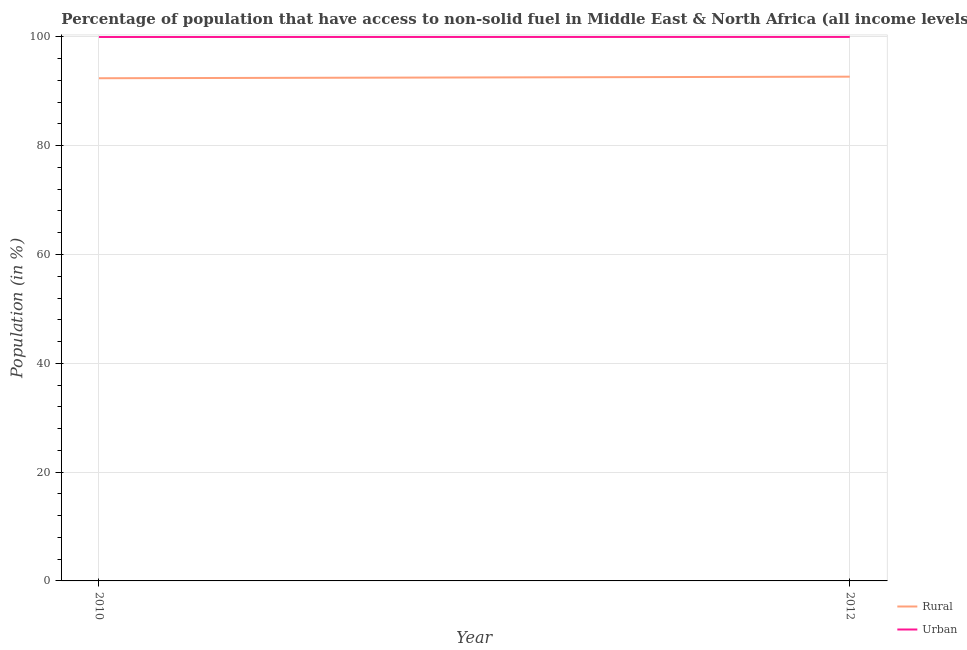Does the line corresponding to rural population intersect with the line corresponding to urban population?
Provide a succinct answer. No. Is the number of lines equal to the number of legend labels?
Ensure brevity in your answer.  Yes. What is the urban population in 2010?
Provide a succinct answer. 99.98. Across all years, what is the maximum urban population?
Provide a succinct answer. 99.99. Across all years, what is the minimum rural population?
Your answer should be very brief. 92.4. In which year was the rural population maximum?
Give a very brief answer. 2012. What is the total urban population in the graph?
Provide a succinct answer. 199.97. What is the difference between the rural population in 2010 and that in 2012?
Provide a succinct answer. -0.29. What is the difference between the urban population in 2012 and the rural population in 2010?
Ensure brevity in your answer.  7.59. What is the average rural population per year?
Offer a very short reply. 92.54. In the year 2012, what is the difference between the rural population and urban population?
Offer a terse response. -7.31. What is the ratio of the urban population in 2010 to that in 2012?
Offer a terse response. 1. Is the rural population strictly greater than the urban population over the years?
Offer a terse response. No. Is the rural population strictly less than the urban population over the years?
Ensure brevity in your answer.  Yes. What is the difference between two consecutive major ticks on the Y-axis?
Give a very brief answer. 20. How are the legend labels stacked?
Offer a terse response. Vertical. What is the title of the graph?
Provide a short and direct response. Percentage of population that have access to non-solid fuel in Middle East & North Africa (all income levels). What is the Population (in %) in Rural in 2010?
Offer a very short reply. 92.4. What is the Population (in %) of Urban in 2010?
Your response must be concise. 99.98. What is the Population (in %) in Rural in 2012?
Your answer should be very brief. 92.69. What is the Population (in %) of Urban in 2012?
Offer a very short reply. 99.99. Across all years, what is the maximum Population (in %) of Rural?
Offer a terse response. 92.69. Across all years, what is the maximum Population (in %) of Urban?
Provide a short and direct response. 99.99. Across all years, what is the minimum Population (in %) in Rural?
Provide a succinct answer. 92.4. Across all years, what is the minimum Population (in %) of Urban?
Ensure brevity in your answer.  99.98. What is the total Population (in %) in Rural in the graph?
Your answer should be very brief. 185.09. What is the total Population (in %) of Urban in the graph?
Your answer should be very brief. 199.97. What is the difference between the Population (in %) in Rural in 2010 and that in 2012?
Make the answer very short. -0.29. What is the difference between the Population (in %) of Urban in 2010 and that in 2012?
Give a very brief answer. -0.01. What is the difference between the Population (in %) in Rural in 2010 and the Population (in %) in Urban in 2012?
Give a very brief answer. -7.59. What is the average Population (in %) in Rural per year?
Provide a succinct answer. 92.54. What is the average Population (in %) of Urban per year?
Provide a succinct answer. 99.99. In the year 2010, what is the difference between the Population (in %) in Rural and Population (in %) in Urban?
Offer a terse response. -7.58. In the year 2012, what is the difference between the Population (in %) in Rural and Population (in %) in Urban?
Offer a very short reply. -7.31. What is the ratio of the Population (in %) in Urban in 2010 to that in 2012?
Your answer should be very brief. 1. What is the difference between the highest and the second highest Population (in %) of Rural?
Keep it short and to the point. 0.29. What is the difference between the highest and the second highest Population (in %) in Urban?
Your response must be concise. 0.01. What is the difference between the highest and the lowest Population (in %) in Rural?
Your answer should be compact. 0.29. What is the difference between the highest and the lowest Population (in %) in Urban?
Provide a short and direct response. 0.01. 